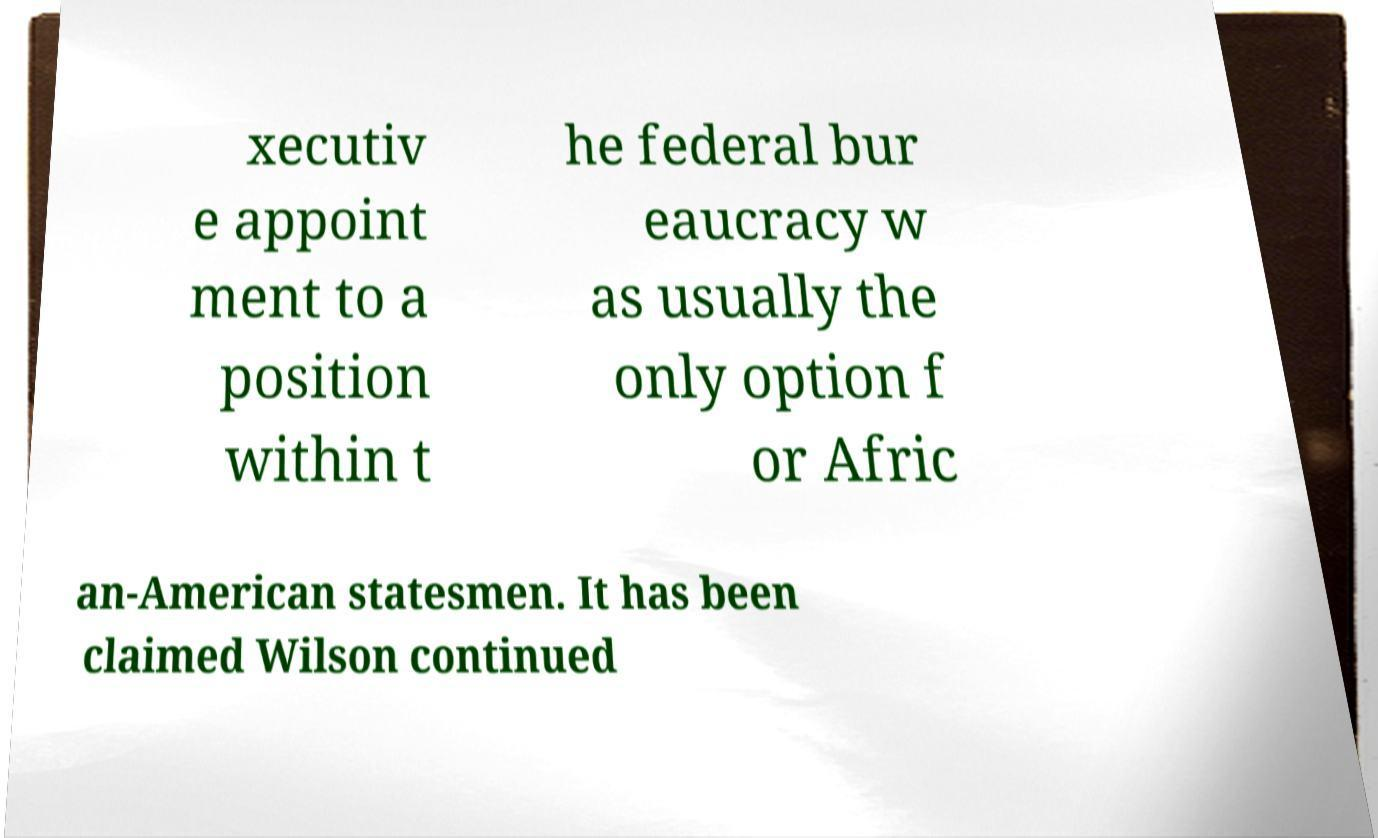Can you read and provide the text displayed in the image?This photo seems to have some interesting text. Can you extract and type it out for me? xecutiv e appoint ment to a position within t he federal bur eaucracy w as usually the only option f or Afric an-American statesmen. It has been claimed Wilson continued 